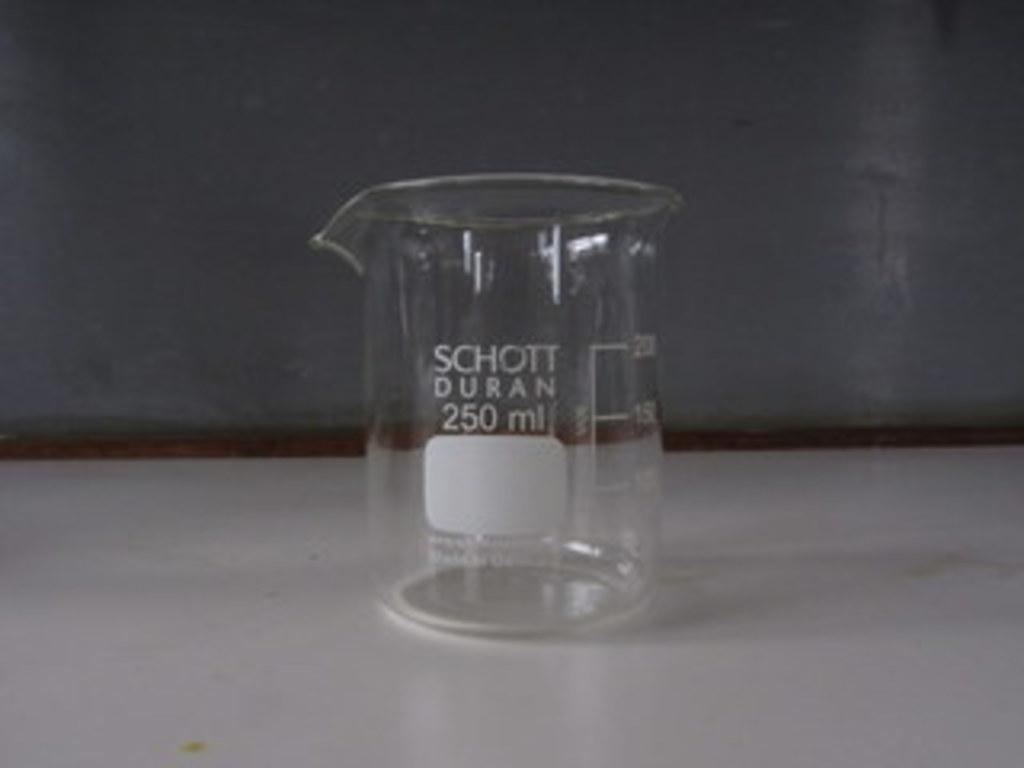<image>
Offer a succinct explanation of the picture presented. An empty glass beaker from Schott Duran is on the table. 